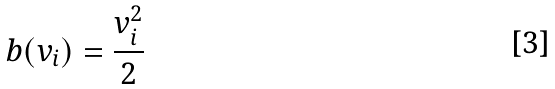Convert formula to latex. <formula><loc_0><loc_0><loc_500><loc_500>b ( v _ { i } ) = { \frac { v _ { i } ^ { 2 } } { 2 } }</formula> 